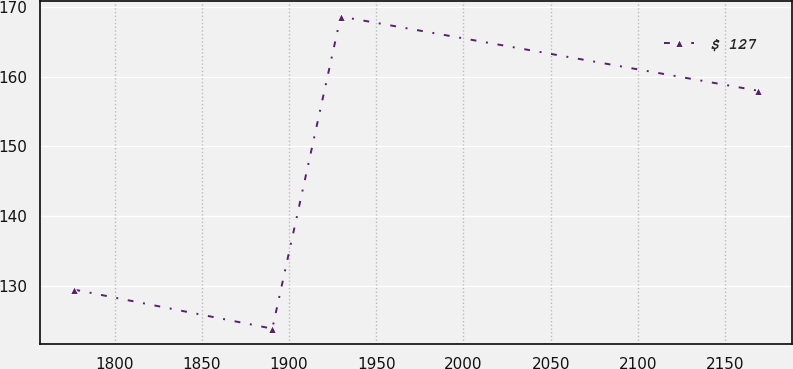Convert chart. <chart><loc_0><loc_0><loc_500><loc_500><line_chart><ecel><fcel>$ 127<nl><fcel>1776.92<fcel>129.42<nl><fcel>1890.42<fcel>123.82<nl><fcel>1929.6<fcel>168.62<nl><fcel>2168.7<fcel>157.98<nl></chart> 